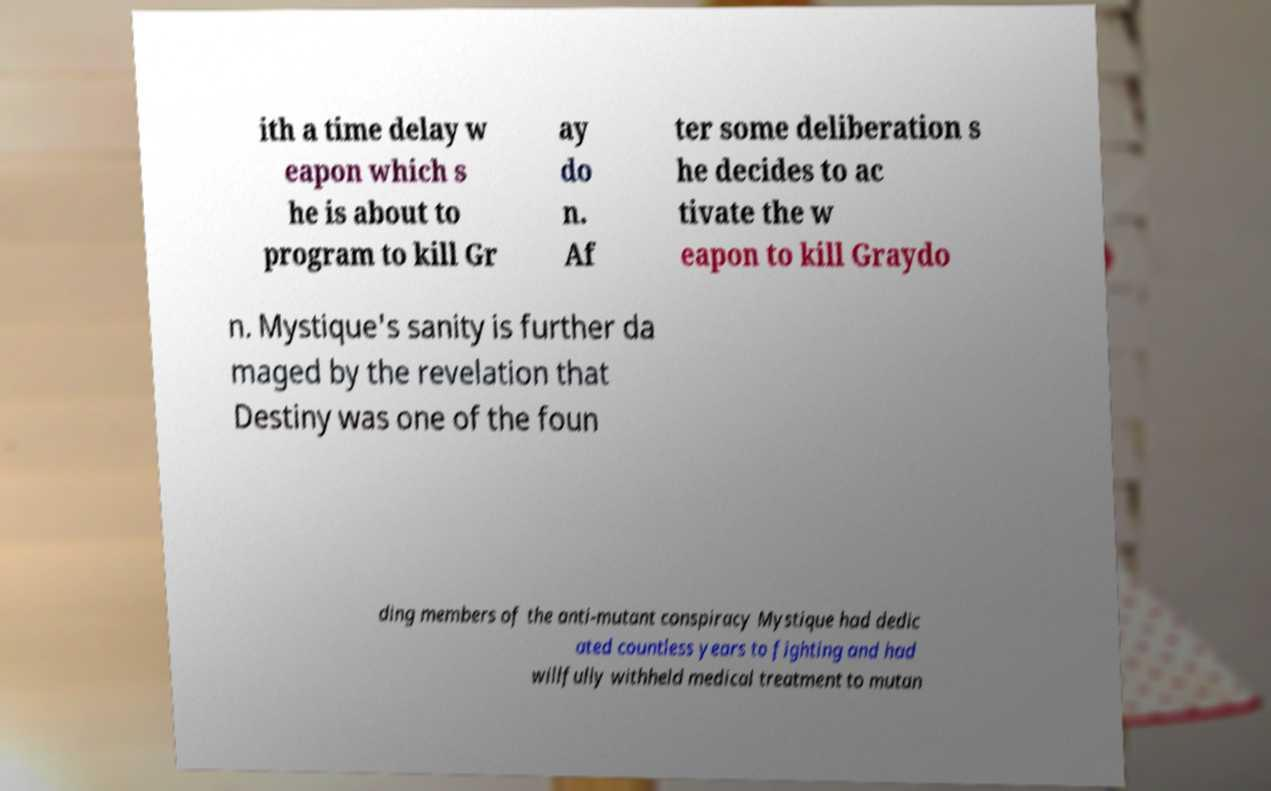For documentation purposes, I need the text within this image transcribed. Could you provide that? ith a time delay w eapon which s he is about to program to kill Gr ay do n. Af ter some deliberation s he decides to ac tivate the w eapon to kill Graydo n. Mystique's sanity is further da maged by the revelation that Destiny was one of the foun ding members of the anti-mutant conspiracy Mystique had dedic ated countless years to fighting and had willfully withheld medical treatment to mutan 